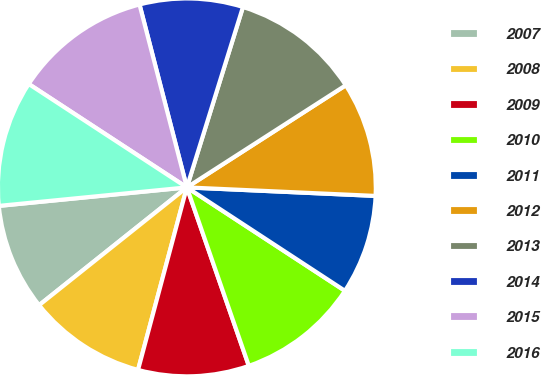Convert chart to OTSL. <chart><loc_0><loc_0><loc_500><loc_500><pie_chart><fcel>2007<fcel>2008<fcel>2009<fcel>2010<fcel>2011<fcel>2012<fcel>2013<fcel>2014<fcel>2015<fcel>2016<nl><fcel>9.15%<fcel>10.13%<fcel>9.48%<fcel>10.46%<fcel>8.5%<fcel>9.81%<fcel>11.11%<fcel>8.83%<fcel>11.75%<fcel>10.78%<nl></chart> 